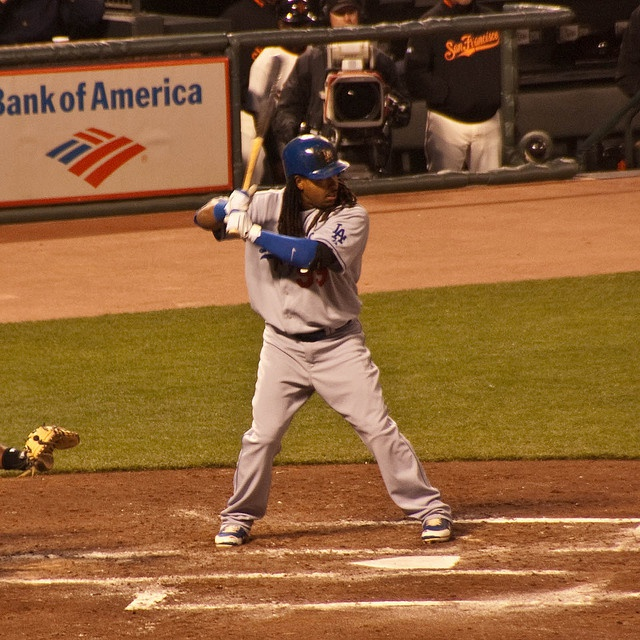Describe the objects in this image and their specific colors. I can see people in brown, tan, black, maroon, and gray tones, people in brown, black, maroon, and gray tones, people in brown, black, and maroon tones, people in black, maroon, and olive tones, and people in brown, black, tan, and maroon tones in this image. 